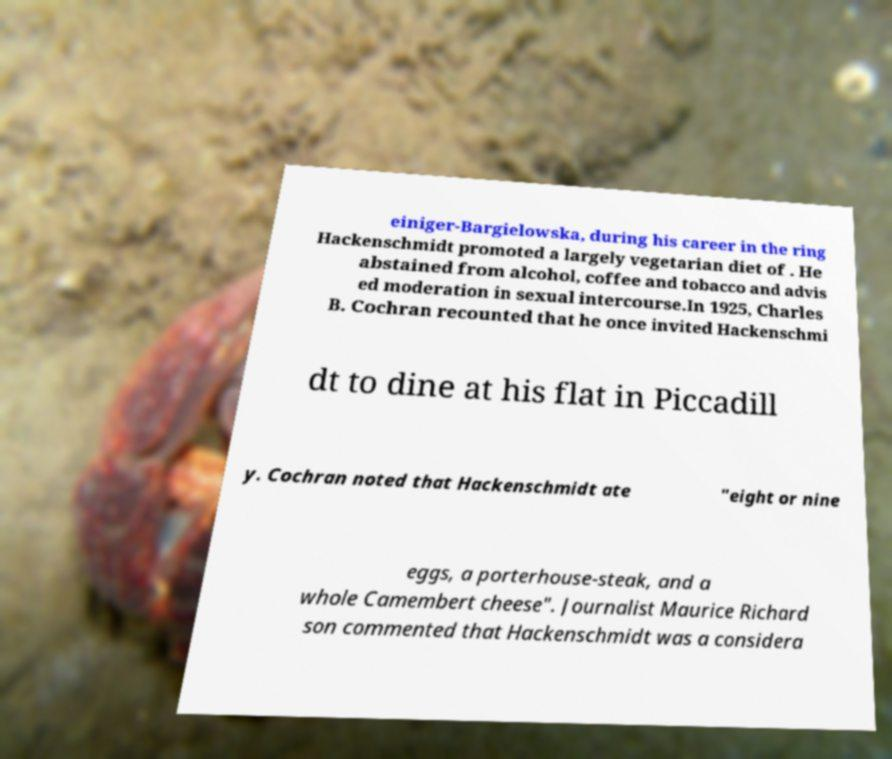There's text embedded in this image that I need extracted. Can you transcribe it verbatim? einiger-Bargielowska, during his career in the ring Hackenschmidt promoted a largely vegetarian diet of . He abstained from alcohol, coffee and tobacco and advis ed moderation in sexual intercourse.In 1925, Charles B. Cochran recounted that he once invited Hackenschmi dt to dine at his flat in Piccadill y. Cochran noted that Hackenschmidt ate "eight or nine eggs, a porterhouse-steak, and a whole Camembert cheese". Journalist Maurice Richard son commented that Hackenschmidt was a considera 